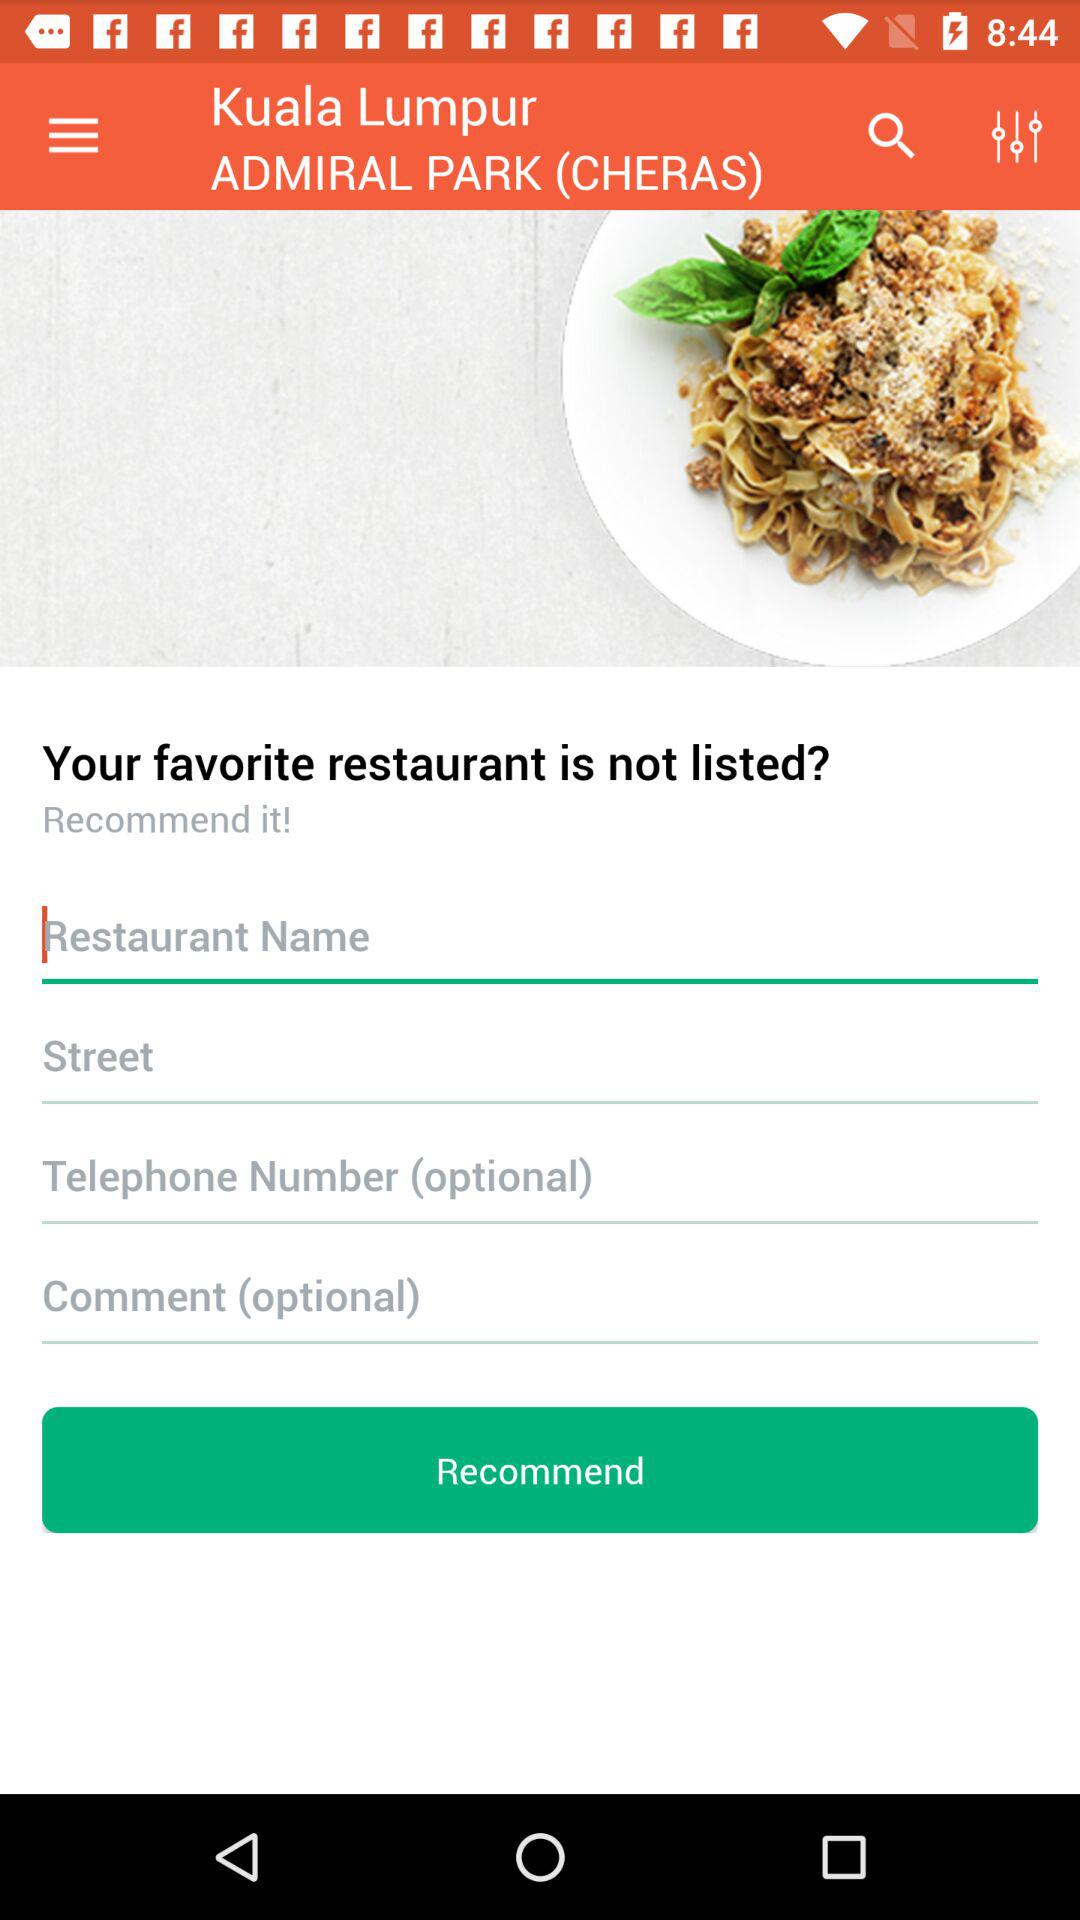What is the city name? The city name is Kuala Lumpur. 